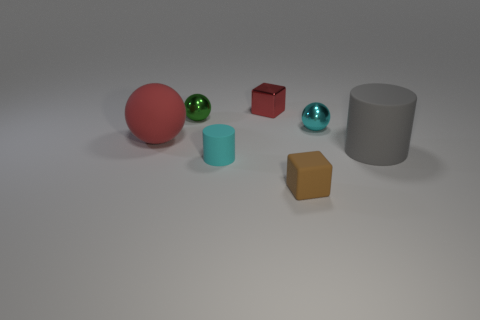Subtract all large red balls. How many balls are left? 2 Subtract all red blocks. How many blocks are left? 1 Add 2 gray cylinders. How many objects exist? 9 Subtract all cylinders. How many objects are left? 5 Subtract all blue rubber objects. Subtract all small metal objects. How many objects are left? 4 Add 4 large red rubber spheres. How many large red rubber spheres are left? 5 Add 3 big matte spheres. How many big matte spheres exist? 4 Subtract 0 green cylinders. How many objects are left? 7 Subtract 1 cubes. How many cubes are left? 1 Subtract all purple blocks. Subtract all purple balls. How many blocks are left? 2 